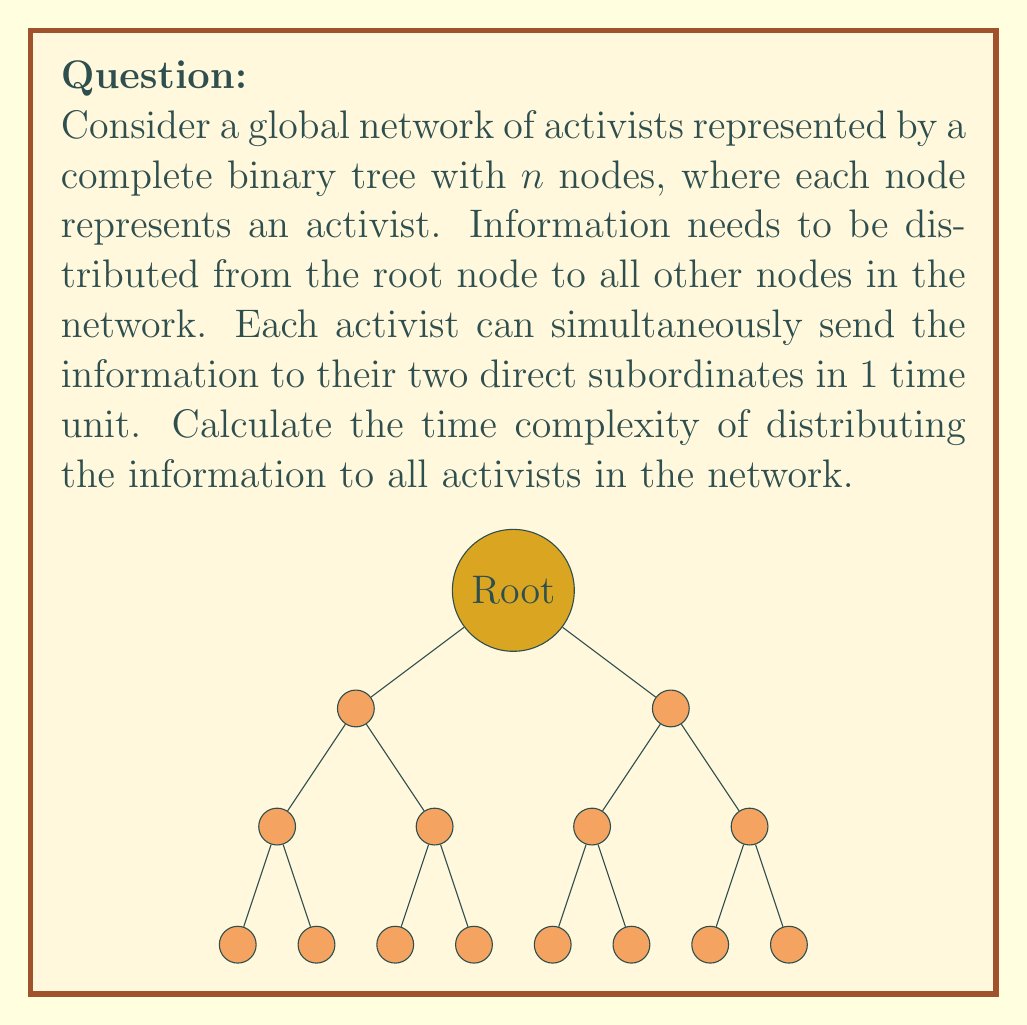Teach me how to tackle this problem. To solve this problem, we need to understand the structure of a complete binary tree and how information propagates through it:

1) In a complete binary tree with $n$ nodes, the height of the tree is $h = \lfloor \log_2 n \rfloor$.

2) Information starts at the root and spreads level by level. Each level can be informed simultaneously.

3) The time taken to inform all nodes is equal to the number of levels that need to be traversed, which is the height of the tree.

4) Therefore, the time complexity of distributing information to all nodes is $O(\log n)$.

Step-by-step explanation:

1) The root node (level 0) has the information at the start.
2) After 1 time unit, both nodes at level 1 receive the information.
3) After 2 time units, all nodes at level 2 receive the information.
4) This continues until the last level is reached.

The number of levels in the tree is $\lfloor \log_2 n \rfloor + 1$, but we don't need to count the root level (as it starts with the information), so the time taken is $\lfloor \log_2 n \rfloor$.

In Big O notation, we express this as $O(\log n)$, which represents the logarithmic time complexity of the information distribution process.
Answer: $O(\log n)$ 